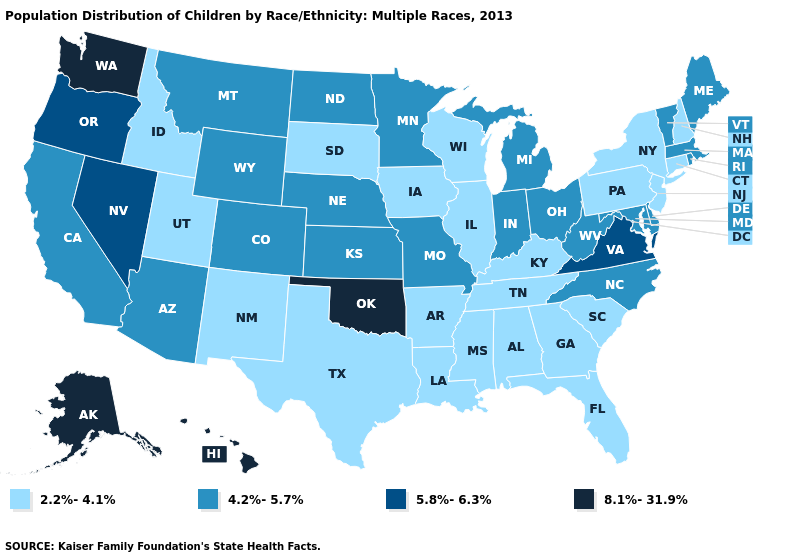Among the states that border New Jersey , does Delaware have the lowest value?
Give a very brief answer. No. What is the highest value in the West ?
Quick response, please. 8.1%-31.9%. Name the states that have a value in the range 2.2%-4.1%?
Give a very brief answer. Alabama, Arkansas, Connecticut, Florida, Georgia, Idaho, Illinois, Iowa, Kentucky, Louisiana, Mississippi, New Hampshire, New Jersey, New Mexico, New York, Pennsylvania, South Carolina, South Dakota, Tennessee, Texas, Utah, Wisconsin. What is the value of New Mexico?
Concise answer only. 2.2%-4.1%. Which states have the lowest value in the MidWest?
Keep it brief. Illinois, Iowa, South Dakota, Wisconsin. Does Rhode Island have the same value as Wyoming?
Write a very short answer. Yes. What is the highest value in states that border Missouri?
Short answer required. 8.1%-31.9%. Which states have the lowest value in the MidWest?
Give a very brief answer. Illinois, Iowa, South Dakota, Wisconsin. Name the states that have a value in the range 5.8%-6.3%?
Concise answer only. Nevada, Oregon, Virginia. What is the lowest value in the USA?
Keep it brief. 2.2%-4.1%. What is the lowest value in the USA?
Answer briefly. 2.2%-4.1%. What is the value of Tennessee?
Be succinct. 2.2%-4.1%. What is the value of Louisiana?
Short answer required. 2.2%-4.1%. What is the lowest value in the USA?
Write a very short answer. 2.2%-4.1%. Name the states that have a value in the range 8.1%-31.9%?
Keep it brief. Alaska, Hawaii, Oklahoma, Washington. 